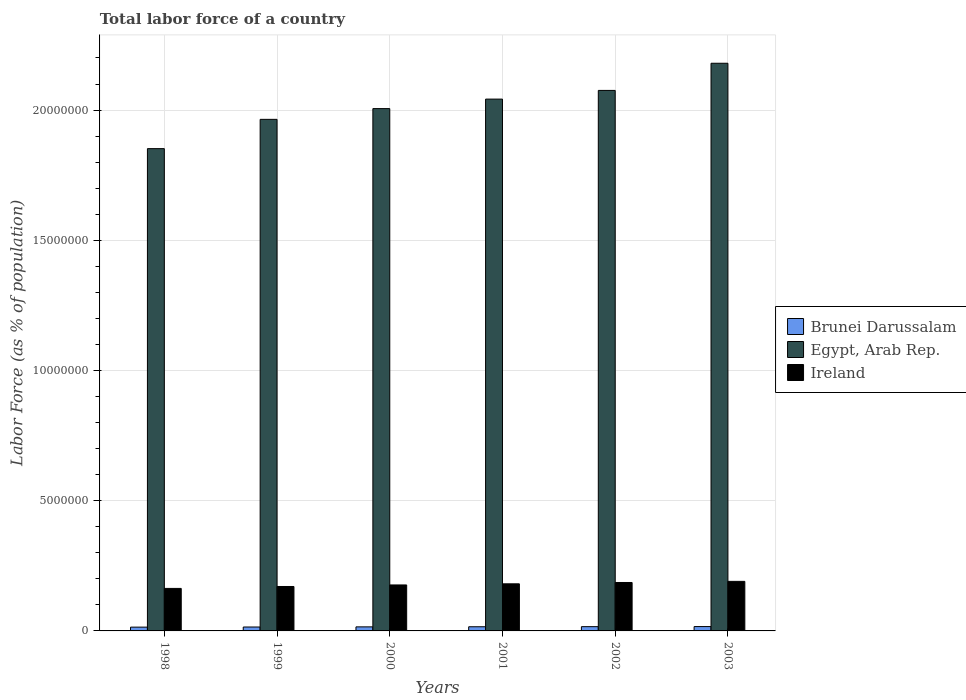Are the number of bars per tick equal to the number of legend labels?
Offer a very short reply. Yes. Are the number of bars on each tick of the X-axis equal?
Provide a succinct answer. Yes. How many bars are there on the 6th tick from the left?
Offer a very short reply. 3. What is the percentage of labor force in Egypt, Arab Rep. in 2001?
Give a very brief answer. 2.04e+07. Across all years, what is the maximum percentage of labor force in Ireland?
Offer a very short reply. 1.90e+06. Across all years, what is the minimum percentage of labor force in Egypt, Arab Rep.?
Your response must be concise. 1.85e+07. What is the total percentage of labor force in Ireland in the graph?
Keep it short and to the point. 1.07e+07. What is the difference between the percentage of labor force in Brunei Darussalam in 1998 and that in 1999?
Give a very brief answer. -5076. What is the difference between the percentage of labor force in Ireland in 1998 and the percentage of labor force in Brunei Darussalam in 1999?
Provide a succinct answer. 1.48e+06. What is the average percentage of labor force in Egypt, Arab Rep. per year?
Make the answer very short. 2.02e+07. In the year 2000, what is the difference between the percentage of labor force in Ireland and percentage of labor force in Egypt, Arab Rep.?
Your answer should be compact. -1.83e+07. What is the ratio of the percentage of labor force in Ireland in 1999 to that in 2002?
Make the answer very short. 0.92. Is the difference between the percentage of labor force in Ireland in 2001 and 2003 greater than the difference between the percentage of labor force in Egypt, Arab Rep. in 2001 and 2003?
Provide a short and direct response. Yes. What is the difference between the highest and the second highest percentage of labor force in Ireland?
Ensure brevity in your answer.  4.31e+04. What is the difference between the highest and the lowest percentage of labor force in Brunei Darussalam?
Provide a succinct answer. 2.18e+04. What does the 2nd bar from the left in 2001 represents?
Offer a terse response. Egypt, Arab Rep. What does the 2nd bar from the right in 2002 represents?
Give a very brief answer. Egypt, Arab Rep. Is it the case that in every year, the sum of the percentage of labor force in Brunei Darussalam and percentage of labor force in Egypt, Arab Rep. is greater than the percentage of labor force in Ireland?
Provide a short and direct response. Yes. How many bars are there?
Your response must be concise. 18. How many years are there in the graph?
Offer a very short reply. 6. What is the difference between two consecutive major ticks on the Y-axis?
Your response must be concise. 5.00e+06. What is the title of the graph?
Provide a succinct answer. Total labor force of a country. Does "Brunei Darussalam" appear as one of the legend labels in the graph?
Give a very brief answer. Yes. What is the label or title of the Y-axis?
Offer a terse response. Labor Force (as % of population). What is the Labor Force (as % of population) of Brunei Darussalam in 1998?
Offer a very short reply. 1.45e+05. What is the Labor Force (as % of population) in Egypt, Arab Rep. in 1998?
Keep it short and to the point. 1.85e+07. What is the Labor Force (as % of population) in Ireland in 1998?
Provide a short and direct response. 1.63e+06. What is the Labor Force (as % of population) in Brunei Darussalam in 1999?
Your answer should be compact. 1.51e+05. What is the Labor Force (as % of population) of Egypt, Arab Rep. in 1999?
Your answer should be very brief. 1.96e+07. What is the Labor Force (as % of population) in Ireland in 1999?
Offer a very short reply. 1.71e+06. What is the Labor Force (as % of population) of Brunei Darussalam in 2000?
Keep it short and to the point. 1.55e+05. What is the Labor Force (as % of population) of Egypt, Arab Rep. in 2000?
Your response must be concise. 2.01e+07. What is the Labor Force (as % of population) of Ireland in 2000?
Your answer should be very brief. 1.77e+06. What is the Labor Force (as % of population) in Brunei Darussalam in 2001?
Your answer should be very brief. 1.60e+05. What is the Labor Force (as % of population) in Egypt, Arab Rep. in 2001?
Your response must be concise. 2.04e+07. What is the Labor Force (as % of population) in Ireland in 2001?
Keep it short and to the point. 1.81e+06. What is the Labor Force (as % of population) of Brunei Darussalam in 2002?
Provide a short and direct response. 1.64e+05. What is the Labor Force (as % of population) in Egypt, Arab Rep. in 2002?
Ensure brevity in your answer.  2.08e+07. What is the Labor Force (as % of population) in Ireland in 2002?
Your response must be concise. 1.86e+06. What is the Labor Force (as % of population) in Brunei Darussalam in 2003?
Offer a terse response. 1.67e+05. What is the Labor Force (as % of population) of Egypt, Arab Rep. in 2003?
Give a very brief answer. 2.18e+07. What is the Labor Force (as % of population) in Ireland in 2003?
Your answer should be compact. 1.90e+06. Across all years, what is the maximum Labor Force (as % of population) in Brunei Darussalam?
Keep it short and to the point. 1.67e+05. Across all years, what is the maximum Labor Force (as % of population) in Egypt, Arab Rep.?
Offer a terse response. 2.18e+07. Across all years, what is the maximum Labor Force (as % of population) of Ireland?
Provide a short and direct response. 1.90e+06. Across all years, what is the minimum Labor Force (as % of population) of Brunei Darussalam?
Provide a short and direct response. 1.45e+05. Across all years, what is the minimum Labor Force (as % of population) in Egypt, Arab Rep.?
Give a very brief answer. 1.85e+07. Across all years, what is the minimum Labor Force (as % of population) of Ireland?
Keep it short and to the point. 1.63e+06. What is the total Labor Force (as % of population) in Brunei Darussalam in the graph?
Give a very brief answer. 9.42e+05. What is the total Labor Force (as % of population) of Egypt, Arab Rep. in the graph?
Make the answer very short. 1.21e+08. What is the total Labor Force (as % of population) in Ireland in the graph?
Your answer should be compact. 1.07e+07. What is the difference between the Labor Force (as % of population) of Brunei Darussalam in 1998 and that in 1999?
Offer a very short reply. -5076. What is the difference between the Labor Force (as % of population) of Egypt, Arab Rep. in 1998 and that in 1999?
Your answer should be very brief. -1.12e+06. What is the difference between the Labor Force (as % of population) of Ireland in 1998 and that in 1999?
Make the answer very short. -7.36e+04. What is the difference between the Labor Force (as % of population) in Brunei Darussalam in 1998 and that in 2000?
Offer a very short reply. -1.00e+04. What is the difference between the Labor Force (as % of population) of Egypt, Arab Rep. in 1998 and that in 2000?
Make the answer very short. -1.54e+06. What is the difference between the Labor Force (as % of population) in Ireland in 1998 and that in 2000?
Offer a terse response. -1.33e+05. What is the difference between the Labor Force (as % of population) in Brunei Darussalam in 1998 and that in 2001?
Give a very brief answer. -1.46e+04. What is the difference between the Labor Force (as % of population) of Egypt, Arab Rep. in 1998 and that in 2001?
Keep it short and to the point. -1.90e+06. What is the difference between the Labor Force (as % of population) in Ireland in 1998 and that in 2001?
Keep it short and to the point. -1.76e+05. What is the difference between the Labor Force (as % of population) of Brunei Darussalam in 1998 and that in 2002?
Provide a short and direct response. -1.82e+04. What is the difference between the Labor Force (as % of population) in Egypt, Arab Rep. in 1998 and that in 2002?
Provide a succinct answer. -2.24e+06. What is the difference between the Labor Force (as % of population) of Ireland in 1998 and that in 2002?
Your answer should be compact. -2.27e+05. What is the difference between the Labor Force (as % of population) in Brunei Darussalam in 1998 and that in 2003?
Make the answer very short. -2.18e+04. What is the difference between the Labor Force (as % of population) of Egypt, Arab Rep. in 1998 and that in 2003?
Make the answer very short. -3.28e+06. What is the difference between the Labor Force (as % of population) in Ireland in 1998 and that in 2003?
Make the answer very short. -2.70e+05. What is the difference between the Labor Force (as % of population) of Brunei Darussalam in 1999 and that in 2000?
Keep it short and to the point. -4948. What is the difference between the Labor Force (as % of population) of Egypt, Arab Rep. in 1999 and that in 2000?
Offer a very short reply. -4.13e+05. What is the difference between the Labor Force (as % of population) in Ireland in 1999 and that in 2000?
Provide a succinct answer. -5.94e+04. What is the difference between the Labor Force (as % of population) of Brunei Darussalam in 1999 and that in 2001?
Provide a succinct answer. -9478. What is the difference between the Labor Force (as % of population) of Egypt, Arab Rep. in 1999 and that in 2001?
Your response must be concise. -7.78e+05. What is the difference between the Labor Force (as % of population) in Ireland in 1999 and that in 2001?
Offer a very short reply. -1.03e+05. What is the difference between the Labor Force (as % of population) of Brunei Darussalam in 1999 and that in 2002?
Offer a very short reply. -1.31e+04. What is the difference between the Labor Force (as % of population) in Egypt, Arab Rep. in 1999 and that in 2002?
Provide a short and direct response. -1.11e+06. What is the difference between the Labor Force (as % of population) of Ireland in 1999 and that in 2002?
Offer a very short reply. -1.54e+05. What is the difference between the Labor Force (as % of population) of Brunei Darussalam in 1999 and that in 2003?
Offer a very short reply. -1.67e+04. What is the difference between the Labor Force (as % of population) of Egypt, Arab Rep. in 1999 and that in 2003?
Provide a short and direct response. -2.15e+06. What is the difference between the Labor Force (as % of population) of Ireland in 1999 and that in 2003?
Make the answer very short. -1.97e+05. What is the difference between the Labor Force (as % of population) in Brunei Darussalam in 2000 and that in 2001?
Provide a succinct answer. -4530. What is the difference between the Labor Force (as % of population) of Egypt, Arab Rep. in 2000 and that in 2001?
Provide a short and direct response. -3.65e+05. What is the difference between the Labor Force (as % of population) of Ireland in 2000 and that in 2001?
Keep it short and to the point. -4.33e+04. What is the difference between the Labor Force (as % of population) of Brunei Darussalam in 2000 and that in 2002?
Your response must be concise. -8197. What is the difference between the Labor Force (as % of population) in Egypt, Arab Rep. in 2000 and that in 2002?
Your answer should be very brief. -6.98e+05. What is the difference between the Labor Force (as % of population) of Ireland in 2000 and that in 2002?
Make the answer very short. -9.42e+04. What is the difference between the Labor Force (as % of population) in Brunei Darussalam in 2000 and that in 2003?
Give a very brief answer. -1.18e+04. What is the difference between the Labor Force (as % of population) in Egypt, Arab Rep. in 2000 and that in 2003?
Ensure brevity in your answer.  -1.74e+06. What is the difference between the Labor Force (as % of population) in Ireland in 2000 and that in 2003?
Your answer should be compact. -1.37e+05. What is the difference between the Labor Force (as % of population) in Brunei Darussalam in 2001 and that in 2002?
Offer a very short reply. -3667. What is the difference between the Labor Force (as % of population) in Egypt, Arab Rep. in 2001 and that in 2002?
Your response must be concise. -3.33e+05. What is the difference between the Labor Force (as % of population) of Ireland in 2001 and that in 2002?
Ensure brevity in your answer.  -5.10e+04. What is the difference between the Labor Force (as % of population) of Brunei Darussalam in 2001 and that in 2003?
Keep it short and to the point. -7233. What is the difference between the Labor Force (as % of population) of Egypt, Arab Rep. in 2001 and that in 2003?
Keep it short and to the point. -1.38e+06. What is the difference between the Labor Force (as % of population) of Ireland in 2001 and that in 2003?
Your answer should be very brief. -9.41e+04. What is the difference between the Labor Force (as % of population) in Brunei Darussalam in 2002 and that in 2003?
Make the answer very short. -3566. What is the difference between the Labor Force (as % of population) in Egypt, Arab Rep. in 2002 and that in 2003?
Your response must be concise. -1.04e+06. What is the difference between the Labor Force (as % of population) in Ireland in 2002 and that in 2003?
Keep it short and to the point. -4.31e+04. What is the difference between the Labor Force (as % of population) in Brunei Darussalam in 1998 and the Labor Force (as % of population) in Egypt, Arab Rep. in 1999?
Offer a very short reply. -1.95e+07. What is the difference between the Labor Force (as % of population) of Brunei Darussalam in 1998 and the Labor Force (as % of population) of Ireland in 1999?
Keep it short and to the point. -1.56e+06. What is the difference between the Labor Force (as % of population) in Egypt, Arab Rep. in 1998 and the Labor Force (as % of population) in Ireland in 1999?
Provide a short and direct response. 1.68e+07. What is the difference between the Labor Force (as % of population) in Brunei Darussalam in 1998 and the Labor Force (as % of population) in Egypt, Arab Rep. in 2000?
Provide a succinct answer. -1.99e+07. What is the difference between the Labor Force (as % of population) of Brunei Darussalam in 1998 and the Labor Force (as % of population) of Ireland in 2000?
Provide a short and direct response. -1.62e+06. What is the difference between the Labor Force (as % of population) in Egypt, Arab Rep. in 1998 and the Labor Force (as % of population) in Ireland in 2000?
Make the answer very short. 1.68e+07. What is the difference between the Labor Force (as % of population) of Brunei Darussalam in 1998 and the Labor Force (as % of population) of Egypt, Arab Rep. in 2001?
Give a very brief answer. -2.03e+07. What is the difference between the Labor Force (as % of population) of Brunei Darussalam in 1998 and the Labor Force (as % of population) of Ireland in 2001?
Make the answer very short. -1.66e+06. What is the difference between the Labor Force (as % of population) of Egypt, Arab Rep. in 1998 and the Labor Force (as % of population) of Ireland in 2001?
Your answer should be compact. 1.67e+07. What is the difference between the Labor Force (as % of population) in Brunei Darussalam in 1998 and the Labor Force (as % of population) in Egypt, Arab Rep. in 2002?
Your answer should be very brief. -2.06e+07. What is the difference between the Labor Force (as % of population) of Brunei Darussalam in 1998 and the Labor Force (as % of population) of Ireland in 2002?
Give a very brief answer. -1.71e+06. What is the difference between the Labor Force (as % of population) of Egypt, Arab Rep. in 1998 and the Labor Force (as % of population) of Ireland in 2002?
Offer a very short reply. 1.67e+07. What is the difference between the Labor Force (as % of population) of Brunei Darussalam in 1998 and the Labor Force (as % of population) of Egypt, Arab Rep. in 2003?
Ensure brevity in your answer.  -2.17e+07. What is the difference between the Labor Force (as % of population) of Brunei Darussalam in 1998 and the Labor Force (as % of population) of Ireland in 2003?
Your answer should be very brief. -1.76e+06. What is the difference between the Labor Force (as % of population) of Egypt, Arab Rep. in 1998 and the Labor Force (as % of population) of Ireland in 2003?
Make the answer very short. 1.66e+07. What is the difference between the Labor Force (as % of population) in Brunei Darussalam in 1999 and the Labor Force (as % of population) in Egypt, Arab Rep. in 2000?
Offer a terse response. -1.99e+07. What is the difference between the Labor Force (as % of population) in Brunei Darussalam in 1999 and the Labor Force (as % of population) in Ireland in 2000?
Ensure brevity in your answer.  -1.61e+06. What is the difference between the Labor Force (as % of population) in Egypt, Arab Rep. in 1999 and the Labor Force (as % of population) in Ireland in 2000?
Your answer should be very brief. 1.79e+07. What is the difference between the Labor Force (as % of population) of Brunei Darussalam in 1999 and the Labor Force (as % of population) of Egypt, Arab Rep. in 2001?
Give a very brief answer. -2.03e+07. What is the difference between the Labor Force (as % of population) of Brunei Darussalam in 1999 and the Labor Force (as % of population) of Ireland in 2001?
Provide a succinct answer. -1.66e+06. What is the difference between the Labor Force (as % of population) of Egypt, Arab Rep. in 1999 and the Labor Force (as % of population) of Ireland in 2001?
Ensure brevity in your answer.  1.78e+07. What is the difference between the Labor Force (as % of population) of Brunei Darussalam in 1999 and the Labor Force (as % of population) of Egypt, Arab Rep. in 2002?
Your answer should be compact. -2.06e+07. What is the difference between the Labor Force (as % of population) in Brunei Darussalam in 1999 and the Labor Force (as % of population) in Ireland in 2002?
Offer a very short reply. -1.71e+06. What is the difference between the Labor Force (as % of population) in Egypt, Arab Rep. in 1999 and the Labor Force (as % of population) in Ireland in 2002?
Provide a succinct answer. 1.78e+07. What is the difference between the Labor Force (as % of population) in Brunei Darussalam in 1999 and the Labor Force (as % of population) in Egypt, Arab Rep. in 2003?
Offer a terse response. -2.16e+07. What is the difference between the Labor Force (as % of population) of Brunei Darussalam in 1999 and the Labor Force (as % of population) of Ireland in 2003?
Your response must be concise. -1.75e+06. What is the difference between the Labor Force (as % of population) in Egypt, Arab Rep. in 1999 and the Labor Force (as % of population) in Ireland in 2003?
Provide a succinct answer. 1.77e+07. What is the difference between the Labor Force (as % of population) of Brunei Darussalam in 2000 and the Labor Force (as % of population) of Egypt, Arab Rep. in 2001?
Your answer should be very brief. -2.03e+07. What is the difference between the Labor Force (as % of population) of Brunei Darussalam in 2000 and the Labor Force (as % of population) of Ireland in 2001?
Provide a short and direct response. -1.65e+06. What is the difference between the Labor Force (as % of population) of Egypt, Arab Rep. in 2000 and the Labor Force (as % of population) of Ireland in 2001?
Make the answer very short. 1.82e+07. What is the difference between the Labor Force (as % of population) of Brunei Darussalam in 2000 and the Labor Force (as % of population) of Egypt, Arab Rep. in 2002?
Your answer should be compact. -2.06e+07. What is the difference between the Labor Force (as % of population) in Brunei Darussalam in 2000 and the Labor Force (as % of population) in Ireland in 2002?
Make the answer very short. -1.70e+06. What is the difference between the Labor Force (as % of population) in Egypt, Arab Rep. in 2000 and the Labor Force (as % of population) in Ireland in 2002?
Your answer should be very brief. 1.82e+07. What is the difference between the Labor Force (as % of population) of Brunei Darussalam in 2000 and the Labor Force (as % of population) of Egypt, Arab Rep. in 2003?
Offer a terse response. -2.16e+07. What is the difference between the Labor Force (as % of population) in Brunei Darussalam in 2000 and the Labor Force (as % of population) in Ireland in 2003?
Offer a terse response. -1.75e+06. What is the difference between the Labor Force (as % of population) of Egypt, Arab Rep. in 2000 and the Labor Force (as % of population) of Ireland in 2003?
Provide a succinct answer. 1.82e+07. What is the difference between the Labor Force (as % of population) in Brunei Darussalam in 2001 and the Labor Force (as % of population) in Egypt, Arab Rep. in 2002?
Keep it short and to the point. -2.06e+07. What is the difference between the Labor Force (as % of population) in Brunei Darussalam in 2001 and the Labor Force (as % of population) in Ireland in 2002?
Your answer should be very brief. -1.70e+06. What is the difference between the Labor Force (as % of population) of Egypt, Arab Rep. in 2001 and the Labor Force (as % of population) of Ireland in 2002?
Offer a terse response. 1.86e+07. What is the difference between the Labor Force (as % of population) in Brunei Darussalam in 2001 and the Labor Force (as % of population) in Egypt, Arab Rep. in 2003?
Give a very brief answer. -2.16e+07. What is the difference between the Labor Force (as % of population) of Brunei Darussalam in 2001 and the Labor Force (as % of population) of Ireland in 2003?
Keep it short and to the point. -1.74e+06. What is the difference between the Labor Force (as % of population) of Egypt, Arab Rep. in 2001 and the Labor Force (as % of population) of Ireland in 2003?
Provide a short and direct response. 1.85e+07. What is the difference between the Labor Force (as % of population) of Brunei Darussalam in 2002 and the Labor Force (as % of population) of Egypt, Arab Rep. in 2003?
Offer a terse response. -2.16e+07. What is the difference between the Labor Force (as % of population) of Brunei Darussalam in 2002 and the Labor Force (as % of population) of Ireland in 2003?
Offer a terse response. -1.74e+06. What is the difference between the Labor Force (as % of population) in Egypt, Arab Rep. in 2002 and the Labor Force (as % of population) in Ireland in 2003?
Make the answer very short. 1.89e+07. What is the average Labor Force (as % of population) of Brunei Darussalam per year?
Provide a short and direct response. 1.57e+05. What is the average Labor Force (as % of population) in Egypt, Arab Rep. per year?
Offer a very short reply. 2.02e+07. What is the average Labor Force (as % of population) in Ireland per year?
Your answer should be compact. 1.78e+06. In the year 1998, what is the difference between the Labor Force (as % of population) in Brunei Darussalam and Labor Force (as % of population) in Egypt, Arab Rep.?
Keep it short and to the point. -1.84e+07. In the year 1998, what is the difference between the Labor Force (as % of population) in Brunei Darussalam and Labor Force (as % of population) in Ireland?
Offer a very short reply. -1.49e+06. In the year 1998, what is the difference between the Labor Force (as % of population) of Egypt, Arab Rep. and Labor Force (as % of population) of Ireland?
Your answer should be very brief. 1.69e+07. In the year 1999, what is the difference between the Labor Force (as % of population) in Brunei Darussalam and Labor Force (as % of population) in Egypt, Arab Rep.?
Your response must be concise. -1.95e+07. In the year 1999, what is the difference between the Labor Force (as % of population) of Brunei Darussalam and Labor Force (as % of population) of Ireland?
Make the answer very short. -1.56e+06. In the year 1999, what is the difference between the Labor Force (as % of population) in Egypt, Arab Rep. and Labor Force (as % of population) in Ireland?
Your answer should be compact. 1.79e+07. In the year 2000, what is the difference between the Labor Force (as % of population) in Brunei Darussalam and Labor Force (as % of population) in Egypt, Arab Rep.?
Provide a short and direct response. -1.99e+07. In the year 2000, what is the difference between the Labor Force (as % of population) of Brunei Darussalam and Labor Force (as % of population) of Ireland?
Your answer should be compact. -1.61e+06. In the year 2000, what is the difference between the Labor Force (as % of population) in Egypt, Arab Rep. and Labor Force (as % of population) in Ireland?
Make the answer very short. 1.83e+07. In the year 2001, what is the difference between the Labor Force (as % of population) in Brunei Darussalam and Labor Force (as % of population) in Egypt, Arab Rep.?
Offer a very short reply. -2.03e+07. In the year 2001, what is the difference between the Labor Force (as % of population) in Brunei Darussalam and Labor Force (as % of population) in Ireland?
Provide a succinct answer. -1.65e+06. In the year 2001, what is the difference between the Labor Force (as % of population) in Egypt, Arab Rep. and Labor Force (as % of population) in Ireland?
Give a very brief answer. 1.86e+07. In the year 2002, what is the difference between the Labor Force (as % of population) in Brunei Darussalam and Labor Force (as % of population) in Egypt, Arab Rep.?
Your response must be concise. -2.06e+07. In the year 2002, what is the difference between the Labor Force (as % of population) of Brunei Darussalam and Labor Force (as % of population) of Ireland?
Ensure brevity in your answer.  -1.70e+06. In the year 2002, what is the difference between the Labor Force (as % of population) of Egypt, Arab Rep. and Labor Force (as % of population) of Ireland?
Provide a short and direct response. 1.89e+07. In the year 2003, what is the difference between the Labor Force (as % of population) of Brunei Darussalam and Labor Force (as % of population) of Egypt, Arab Rep.?
Ensure brevity in your answer.  -2.16e+07. In the year 2003, what is the difference between the Labor Force (as % of population) of Brunei Darussalam and Labor Force (as % of population) of Ireland?
Your answer should be compact. -1.74e+06. In the year 2003, what is the difference between the Labor Force (as % of population) of Egypt, Arab Rep. and Labor Force (as % of population) of Ireland?
Make the answer very short. 1.99e+07. What is the ratio of the Labor Force (as % of population) in Brunei Darussalam in 1998 to that in 1999?
Give a very brief answer. 0.97. What is the ratio of the Labor Force (as % of population) of Egypt, Arab Rep. in 1998 to that in 1999?
Your response must be concise. 0.94. What is the ratio of the Labor Force (as % of population) in Ireland in 1998 to that in 1999?
Your response must be concise. 0.96. What is the ratio of the Labor Force (as % of population) of Brunei Darussalam in 1998 to that in 2000?
Ensure brevity in your answer.  0.94. What is the ratio of the Labor Force (as % of population) in Egypt, Arab Rep. in 1998 to that in 2000?
Your answer should be very brief. 0.92. What is the ratio of the Labor Force (as % of population) in Ireland in 1998 to that in 2000?
Make the answer very short. 0.92. What is the ratio of the Labor Force (as % of population) of Brunei Darussalam in 1998 to that in 2001?
Make the answer very short. 0.91. What is the ratio of the Labor Force (as % of population) of Egypt, Arab Rep. in 1998 to that in 2001?
Provide a short and direct response. 0.91. What is the ratio of the Labor Force (as % of population) of Ireland in 1998 to that in 2001?
Offer a terse response. 0.9. What is the ratio of the Labor Force (as % of population) in Brunei Darussalam in 1998 to that in 2002?
Offer a very short reply. 0.89. What is the ratio of the Labor Force (as % of population) of Egypt, Arab Rep. in 1998 to that in 2002?
Your answer should be very brief. 0.89. What is the ratio of the Labor Force (as % of population) in Ireland in 1998 to that in 2002?
Your response must be concise. 0.88. What is the ratio of the Labor Force (as % of population) of Brunei Darussalam in 1998 to that in 2003?
Offer a terse response. 0.87. What is the ratio of the Labor Force (as % of population) of Egypt, Arab Rep. in 1998 to that in 2003?
Keep it short and to the point. 0.85. What is the ratio of the Labor Force (as % of population) in Ireland in 1998 to that in 2003?
Provide a succinct answer. 0.86. What is the ratio of the Labor Force (as % of population) of Brunei Darussalam in 1999 to that in 2000?
Provide a succinct answer. 0.97. What is the ratio of the Labor Force (as % of population) in Egypt, Arab Rep. in 1999 to that in 2000?
Give a very brief answer. 0.98. What is the ratio of the Labor Force (as % of population) in Ireland in 1999 to that in 2000?
Offer a very short reply. 0.97. What is the ratio of the Labor Force (as % of population) in Brunei Darussalam in 1999 to that in 2001?
Offer a terse response. 0.94. What is the ratio of the Labor Force (as % of population) in Egypt, Arab Rep. in 1999 to that in 2001?
Ensure brevity in your answer.  0.96. What is the ratio of the Labor Force (as % of population) in Ireland in 1999 to that in 2001?
Your answer should be compact. 0.94. What is the ratio of the Labor Force (as % of population) of Brunei Darussalam in 1999 to that in 2002?
Ensure brevity in your answer.  0.92. What is the ratio of the Labor Force (as % of population) of Egypt, Arab Rep. in 1999 to that in 2002?
Your answer should be very brief. 0.95. What is the ratio of the Labor Force (as % of population) of Ireland in 1999 to that in 2002?
Your answer should be compact. 0.92. What is the ratio of the Labor Force (as % of population) of Brunei Darussalam in 1999 to that in 2003?
Offer a very short reply. 0.9. What is the ratio of the Labor Force (as % of population) of Egypt, Arab Rep. in 1999 to that in 2003?
Your answer should be compact. 0.9. What is the ratio of the Labor Force (as % of population) of Ireland in 1999 to that in 2003?
Give a very brief answer. 0.9. What is the ratio of the Labor Force (as % of population) of Brunei Darussalam in 2000 to that in 2001?
Keep it short and to the point. 0.97. What is the ratio of the Labor Force (as % of population) in Egypt, Arab Rep. in 2000 to that in 2001?
Offer a terse response. 0.98. What is the ratio of the Labor Force (as % of population) in Ireland in 2000 to that in 2001?
Provide a succinct answer. 0.98. What is the ratio of the Labor Force (as % of population) in Brunei Darussalam in 2000 to that in 2002?
Your response must be concise. 0.95. What is the ratio of the Labor Force (as % of population) of Egypt, Arab Rep. in 2000 to that in 2002?
Keep it short and to the point. 0.97. What is the ratio of the Labor Force (as % of population) in Ireland in 2000 to that in 2002?
Make the answer very short. 0.95. What is the ratio of the Labor Force (as % of population) in Brunei Darussalam in 2000 to that in 2003?
Make the answer very short. 0.93. What is the ratio of the Labor Force (as % of population) in Egypt, Arab Rep. in 2000 to that in 2003?
Your answer should be compact. 0.92. What is the ratio of the Labor Force (as % of population) of Ireland in 2000 to that in 2003?
Offer a terse response. 0.93. What is the ratio of the Labor Force (as % of population) in Brunei Darussalam in 2001 to that in 2002?
Offer a terse response. 0.98. What is the ratio of the Labor Force (as % of population) of Egypt, Arab Rep. in 2001 to that in 2002?
Make the answer very short. 0.98. What is the ratio of the Labor Force (as % of population) in Ireland in 2001 to that in 2002?
Provide a short and direct response. 0.97. What is the ratio of the Labor Force (as % of population) in Brunei Darussalam in 2001 to that in 2003?
Provide a succinct answer. 0.96. What is the ratio of the Labor Force (as % of population) of Egypt, Arab Rep. in 2001 to that in 2003?
Keep it short and to the point. 0.94. What is the ratio of the Labor Force (as % of population) in Ireland in 2001 to that in 2003?
Offer a very short reply. 0.95. What is the ratio of the Labor Force (as % of population) in Brunei Darussalam in 2002 to that in 2003?
Offer a terse response. 0.98. What is the ratio of the Labor Force (as % of population) of Egypt, Arab Rep. in 2002 to that in 2003?
Your response must be concise. 0.95. What is the ratio of the Labor Force (as % of population) in Ireland in 2002 to that in 2003?
Ensure brevity in your answer.  0.98. What is the difference between the highest and the second highest Labor Force (as % of population) in Brunei Darussalam?
Offer a terse response. 3566. What is the difference between the highest and the second highest Labor Force (as % of population) in Egypt, Arab Rep.?
Offer a very short reply. 1.04e+06. What is the difference between the highest and the second highest Labor Force (as % of population) in Ireland?
Offer a very short reply. 4.31e+04. What is the difference between the highest and the lowest Labor Force (as % of population) in Brunei Darussalam?
Keep it short and to the point. 2.18e+04. What is the difference between the highest and the lowest Labor Force (as % of population) of Egypt, Arab Rep.?
Keep it short and to the point. 3.28e+06. What is the difference between the highest and the lowest Labor Force (as % of population) in Ireland?
Keep it short and to the point. 2.70e+05. 